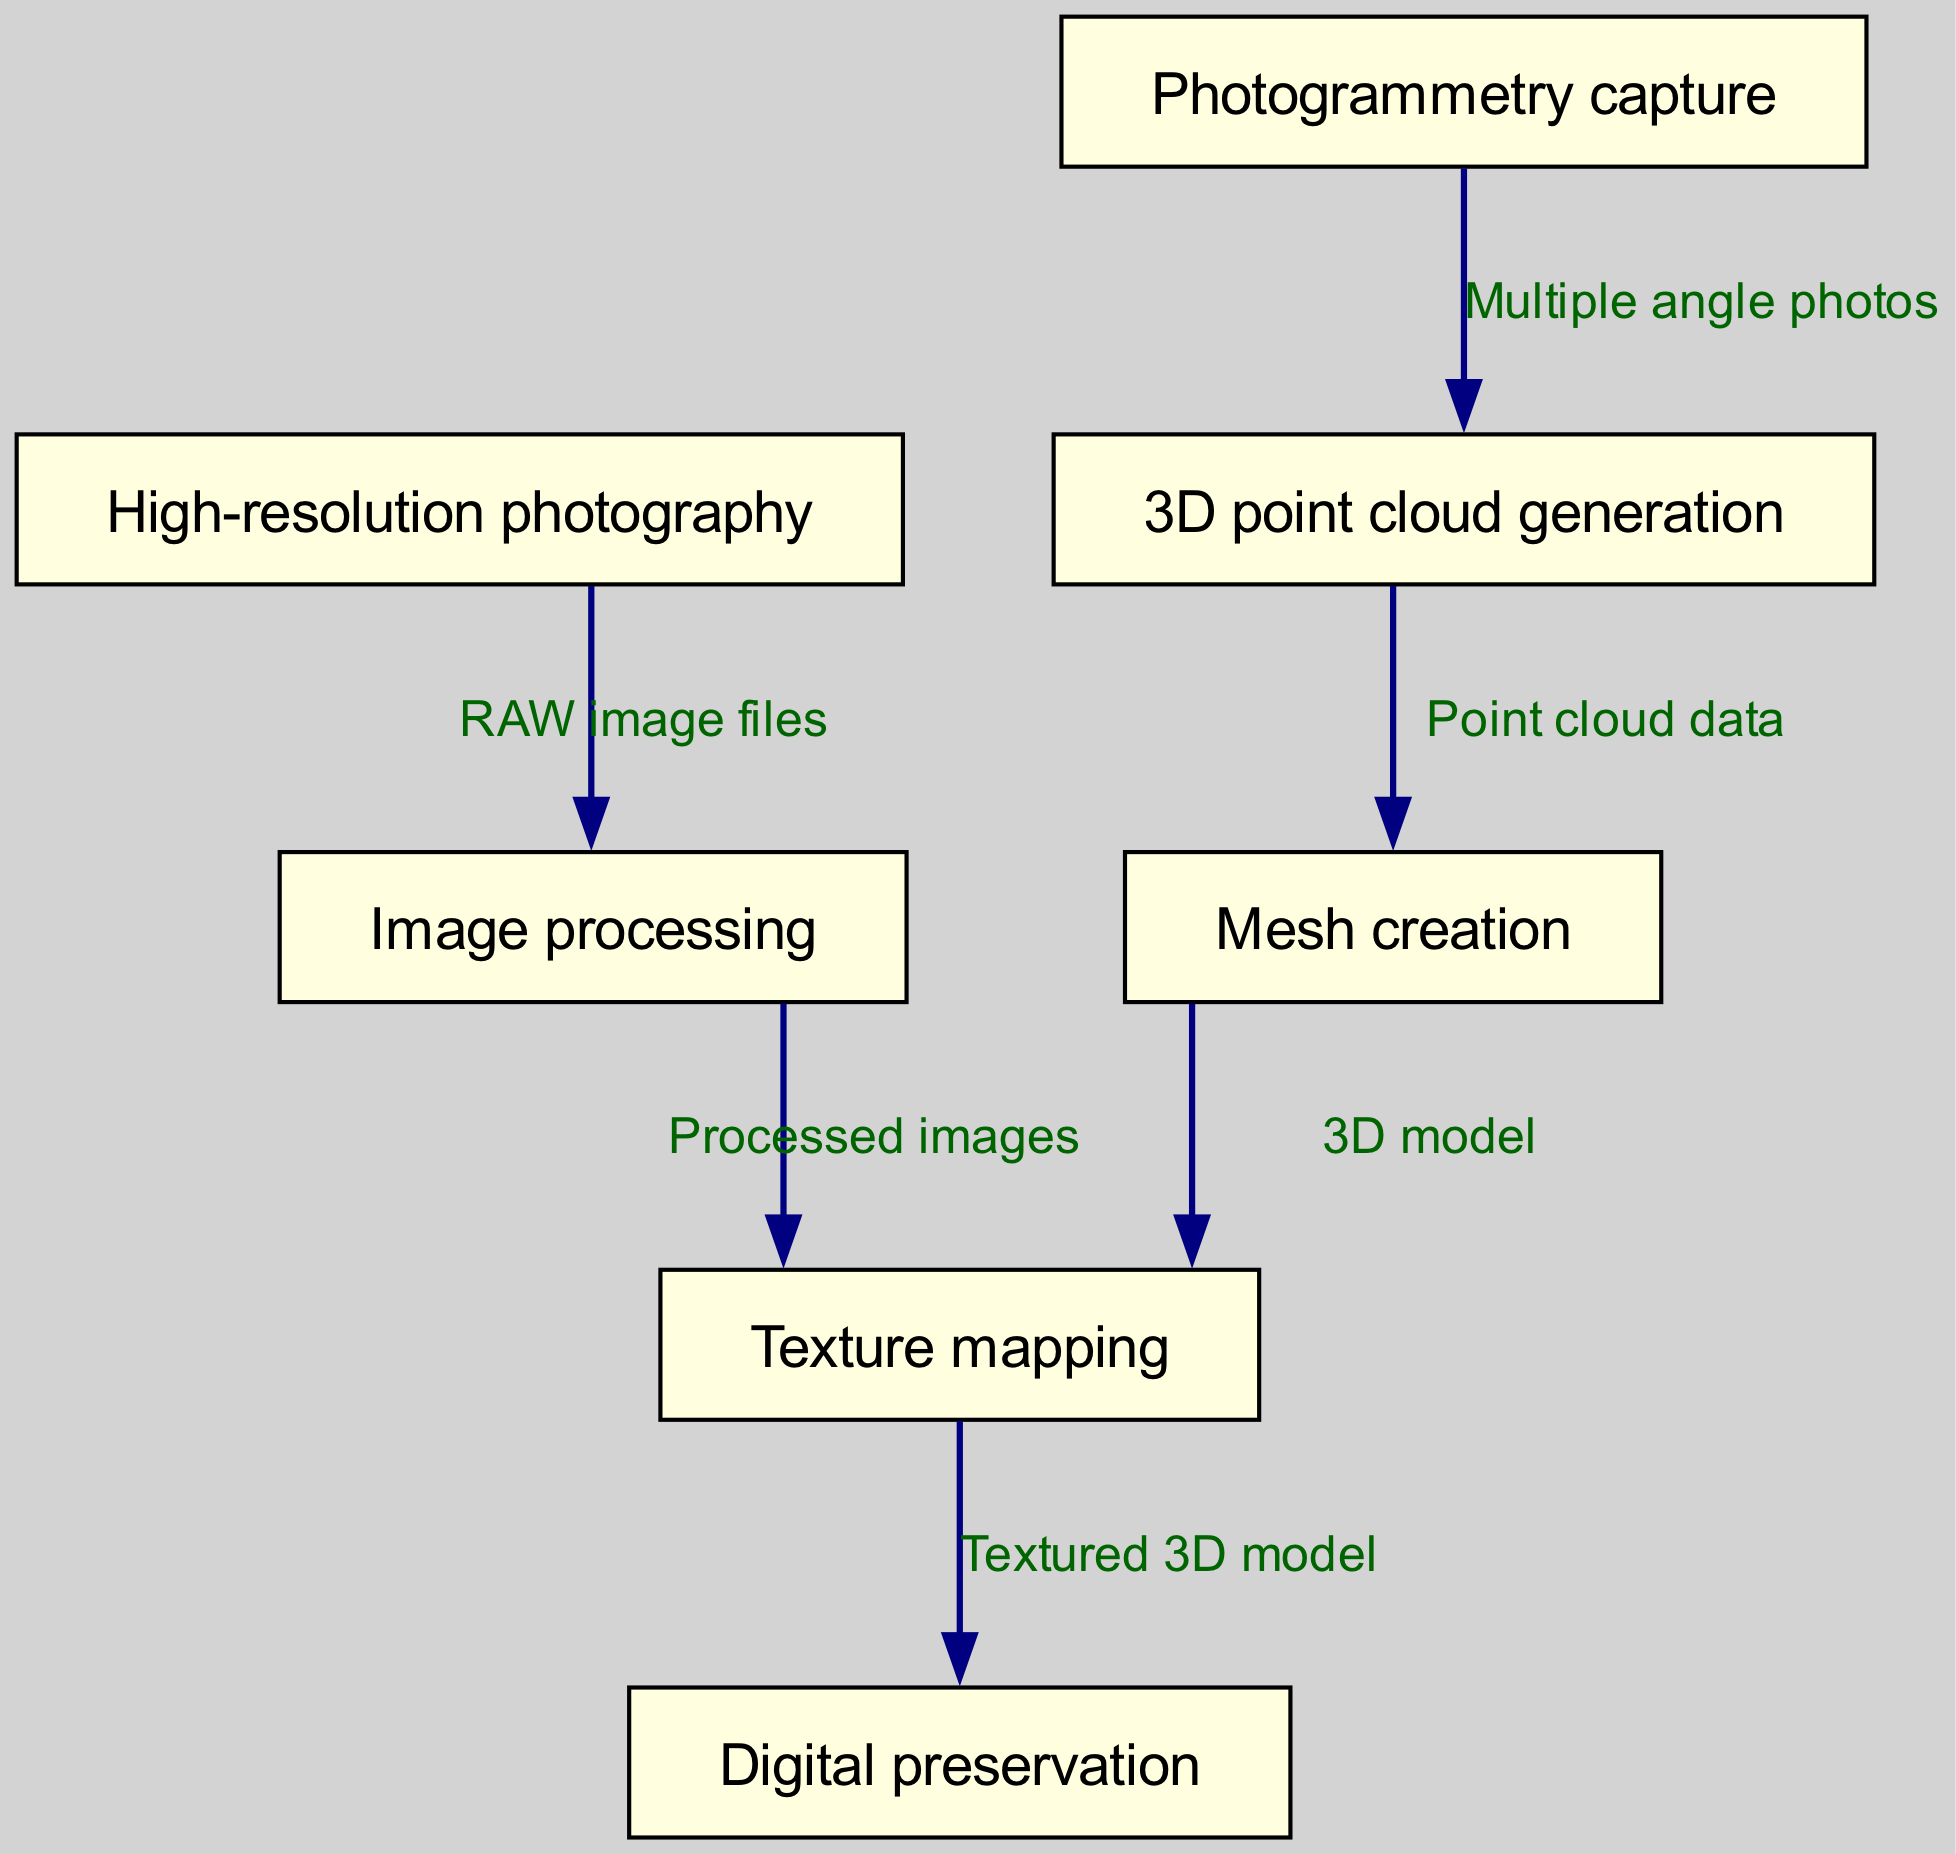What is the first step in the workflow? The first step is represented by the node labeled "High-resolution photography." It is the initial action required to begin the process of creating a digital model of the stone inscriptions.
Answer: High-resolution photography How many nodes are in the diagram? To determine the number of nodes, we count the unique entries listed in the nodes section of the data. There are a total of seven nodes.
Answer: 7 What does the edge from node 1 to node 3 represent? The edge from "High-resolution photography" to "Image processing" is labeled with "RAW image files," indicating that the result of high-resolution photography produces RAW image files that serve as input for the image processing step.
Answer: RAW image files Which node comes directly after "3D point cloud generation"? Looking at the sequence of nodes listed, "Mesh creation" directly follows "3D point cloud generation," indicating the workflow progresses from generating point clouds to constructing meshes from those point clouds.
Answer: Mesh creation What is the final output of the workflow? The final node in the sequence of the diagram is "Digital preservation," which indicates the end goal of the workflow, ensuring that the textured 3D model is preserved digitally.
Answer: Digital preservation What type of data is used to create a 3D model? The edge leading from "Mesh creation" to "Texture mapping" indicates that the process uses "3D model" data, which implies that a mesh is utilized to create the visual representation during texture mapping.
Answer: 3D model How many edges are shown in the diagram? By inspecting the edges section of the data, we can count how many connections there are. There are six distinct edges connecting the nodes.
Answer: 6 What is the connection between "Image processing" and "Texture mapping"? The edge that connects these two nodes indicates that "Processed images" are used during the texture mapping phase, meaning that only images that have undergone processing are employed to apply textures to the 3D model.
Answer: Processed images 